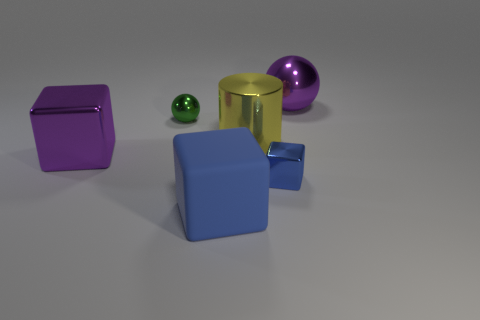Add 1 blocks. How many objects exist? 7 Subtract all spheres. How many objects are left? 4 Subtract all yellow cylinders. Subtract all large purple metallic balls. How many objects are left? 4 Add 6 big purple spheres. How many big purple spheres are left? 7 Add 1 blue shiny objects. How many blue shiny objects exist? 2 Subtract 1 purple balls. How many objects are left? 5 